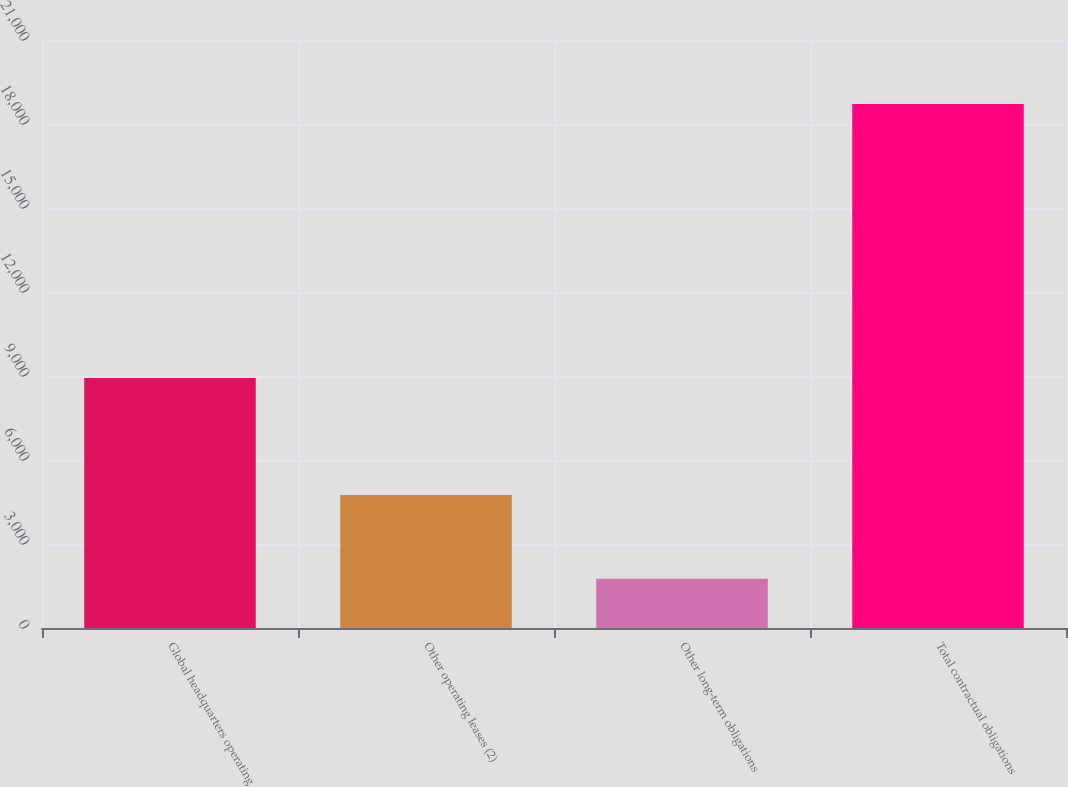<chart> <loc_0><loc_0><loc_500><loc_500><bar_chart><fcel>Global headquarters operating<fcel>Other operating leases (2)<fcel>Other long-term obligations<fcel>Total contractual obligations<nl><fcel>8928<fcel>4752<fcel>1763<fcel>18712<nl></chart> 